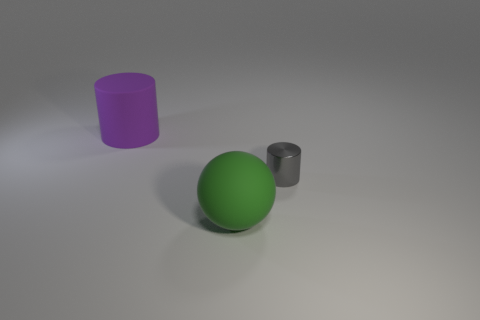Subtract all gray spheres. Subtract all blue cylinders. How many spheres are left? 1 Add 1 cylinders. How many objects exist? 4 Subtract all spheres. How many objects are left? 2 Subtract 0 yellow cubes. How many objects are left? 3 Subtract all tiny red rubber objects. Subtract all green objects. How many objects are left? 2 Add 1 green matte things. How many green matte things are left? 2 Add 2 big blue matte cylinders. How many big blue matte cylinders exist? 2 